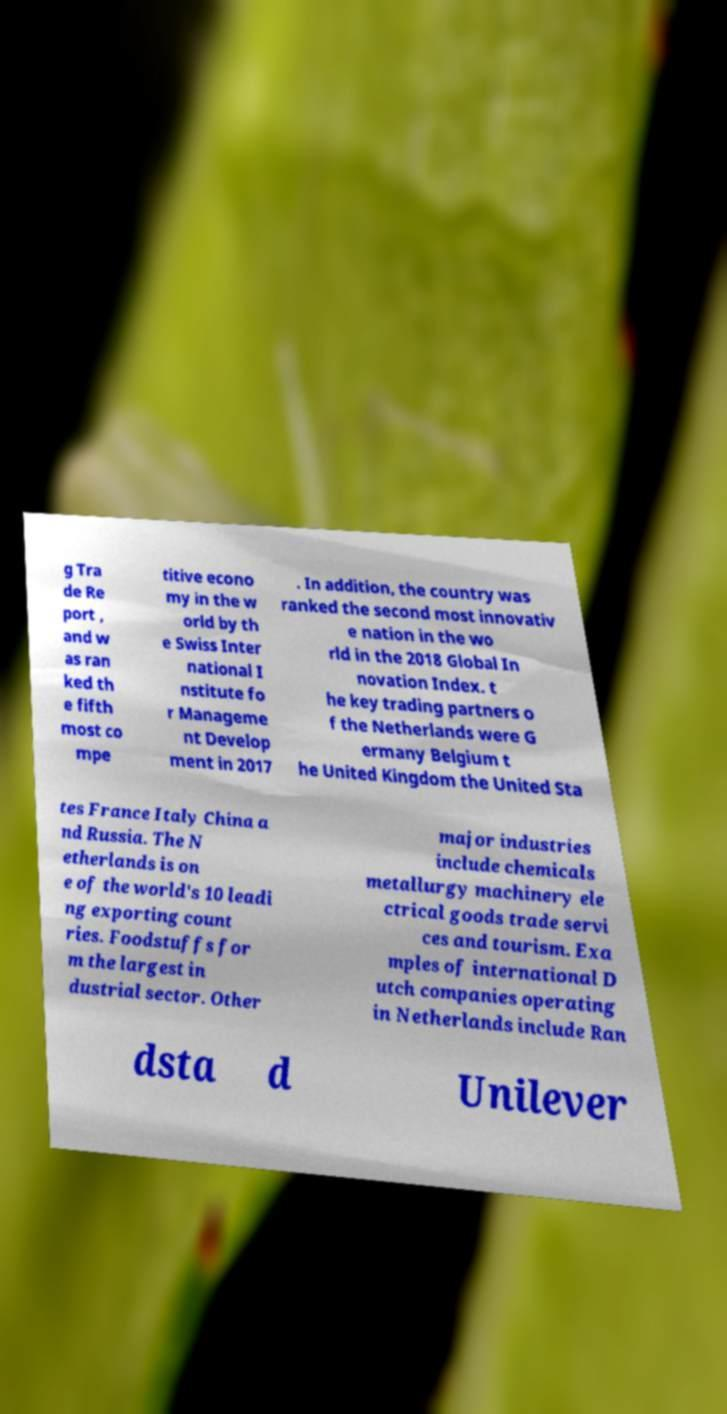Could you extract and type out the text from this image? g Tra de Re port , and w as ran ked th e fifth most co mpe titive econo my in the w orld by th e Swiss Inter national I nstitute fo r Manageme nt Develop ment in 2017 . In addition, the country was ranked the second most innovativ e nation in the wo rld in the 2018 Global In novation Index. t he key trading partners o f the Netherlands were G ermany Belgium t he United Kingdom the United Sta tes France Italy China a nd Russia. The N etherlands is on e of the world's 10 leadi ng exporting count ries. Foodstuffs for m the largest in dustrial sector. Other major industries include chemicals metallurgy machinery ele ctrical goods trade servi ces and tourism. Exa mples of international D utch companies operating in Netherlands include Ran dsta d Unilever 